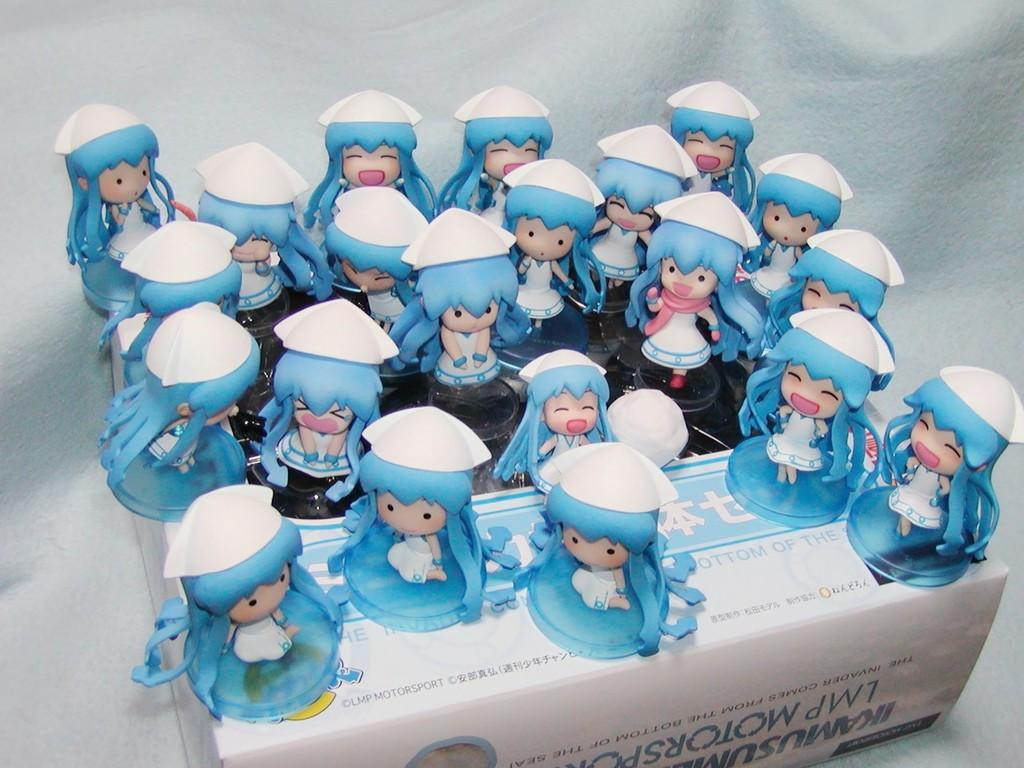What objects are on the box in the image? There are toys on a box in the image. How would you describe the background of the image? The background of the image is colored. Can you make any assumptions about the location where the image was taken? The image may have been taken in a house, as toys are often found in a home setting. What type of trouble is the sponge causing in the image? There is no sponge present in the image, so it cannot be causing any trouble. 